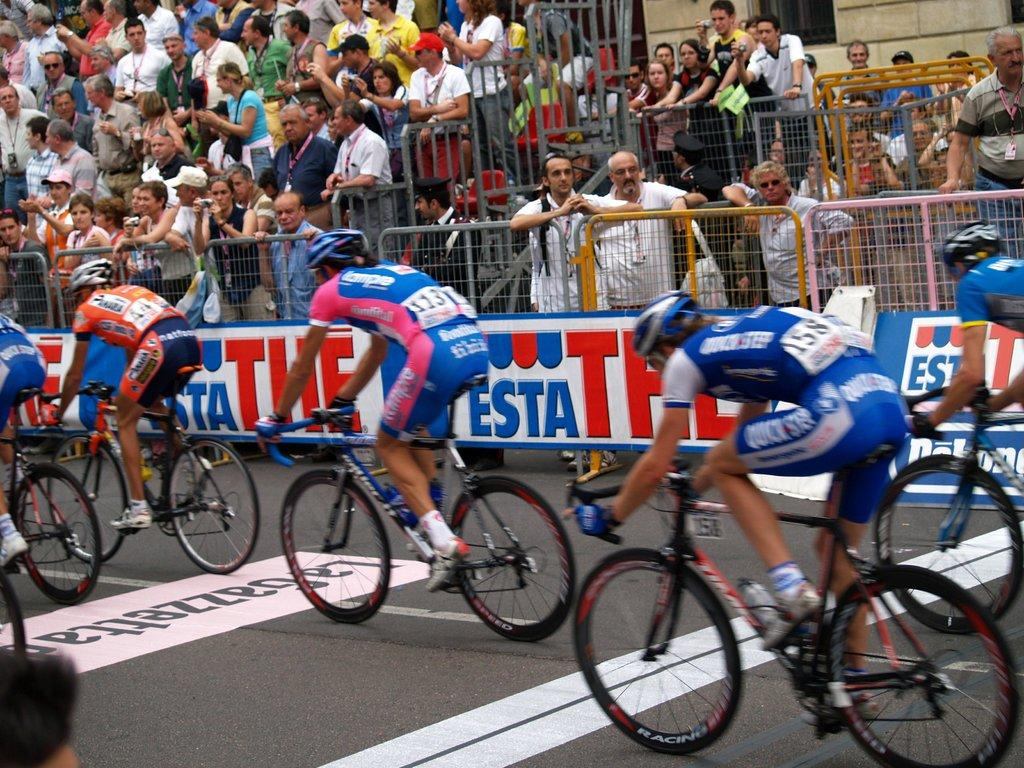<image>
Create a compact narrative representing the image presented. Bicyclist racing on the road that has LaGazzettad across the street in black lettering. 